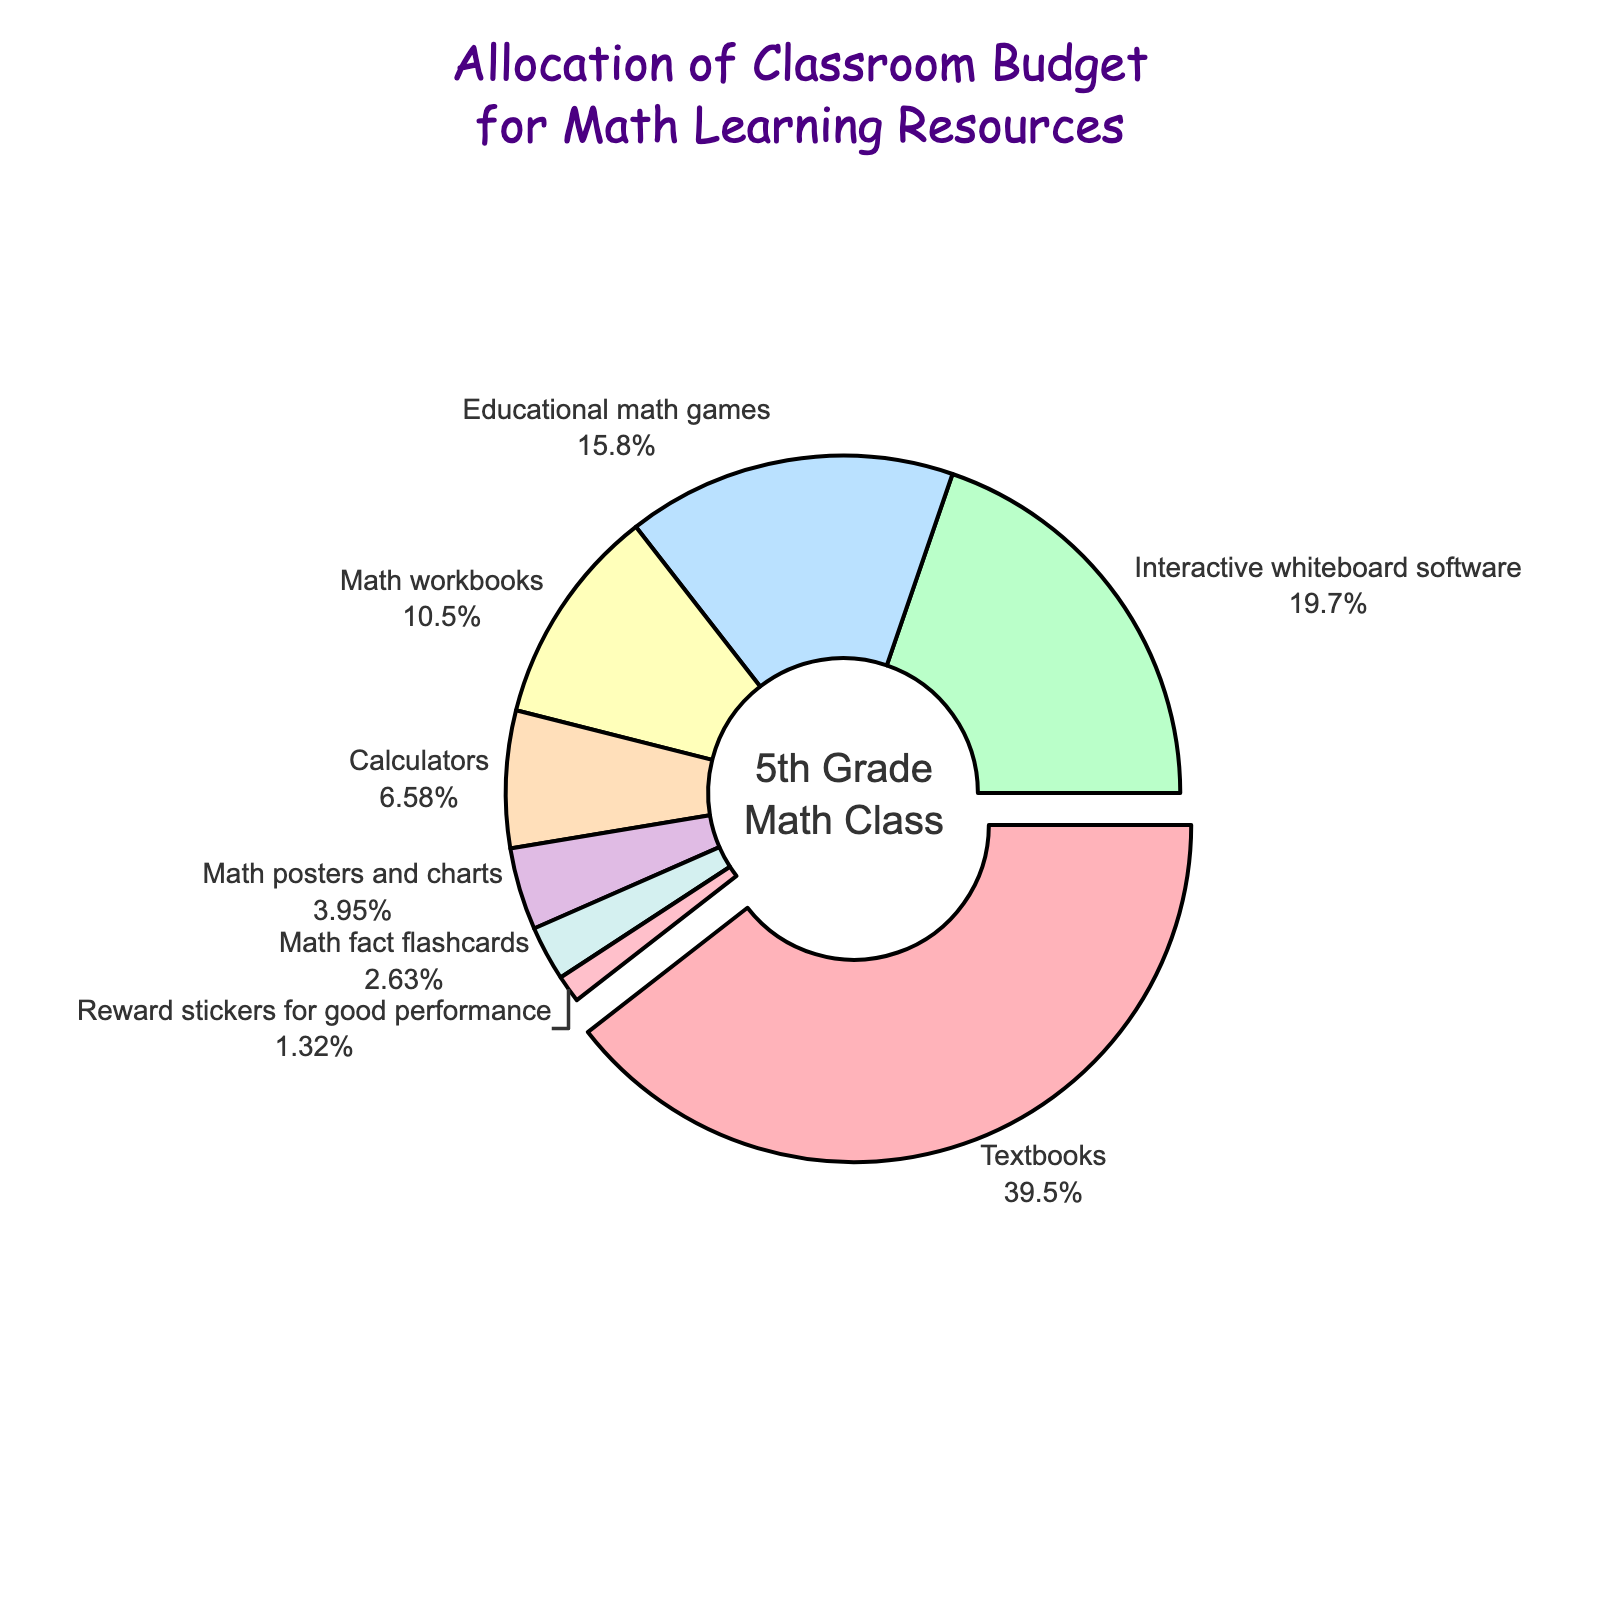What's the percentage allocated to Interactive whiteboard software? Look at the pie chart and find the segment labeled 'Interactive whiteboard software'. The percentage will be displayed there.
Answer: 15 Which resource has the smallest allocation? Find the smallest segment in the pie chart and read the label attached to it.
Answer: Reward stickers for good performance What is the combined percentage of Math workbooks and Calculators? Find the segments for Math workbooks and Calculators. Sum their percentages, which are 8% and 5% respectively.
Answer: 13 Which resource takes up nearly a third of the budget? Observe the segment that is pulled out from the pie chart, labeled 'Textbooks', and note that it has the largest share close to a third.
Answer: Textbooks How much more is allocated to Textbooks than to Educational math games? Look at the segments for Textbooks and Educational math games. Calculate the difference in their percentages: 30% (Textbooks) - 12% (Educational math games).
Answer: 18 What is the percentage combined for resources related to software (Interactive whiteboard software and Educational math games)? Sum the percentages of Interactive whiteboard software (15%) and Educational math games (12%).
Answer: 27 Which resource is allocated more, Calculators or Math posters and charts? Compare the segments of Calculators (5%) and Math posters and charts (3%).
Answer: Calculators What visual aspect makes the Textbooks segment stand out? Identify that the Textbooks segment is slightly separated from the pie chart, distinct from other segments.
Answer: It's pulled out from the pie What percentage is allocated to resources that provide incentives or rewards (Reward stickers)? Find the segment labeled 'Reward stickers for good performance' and note its percentage.
Answer: 1 